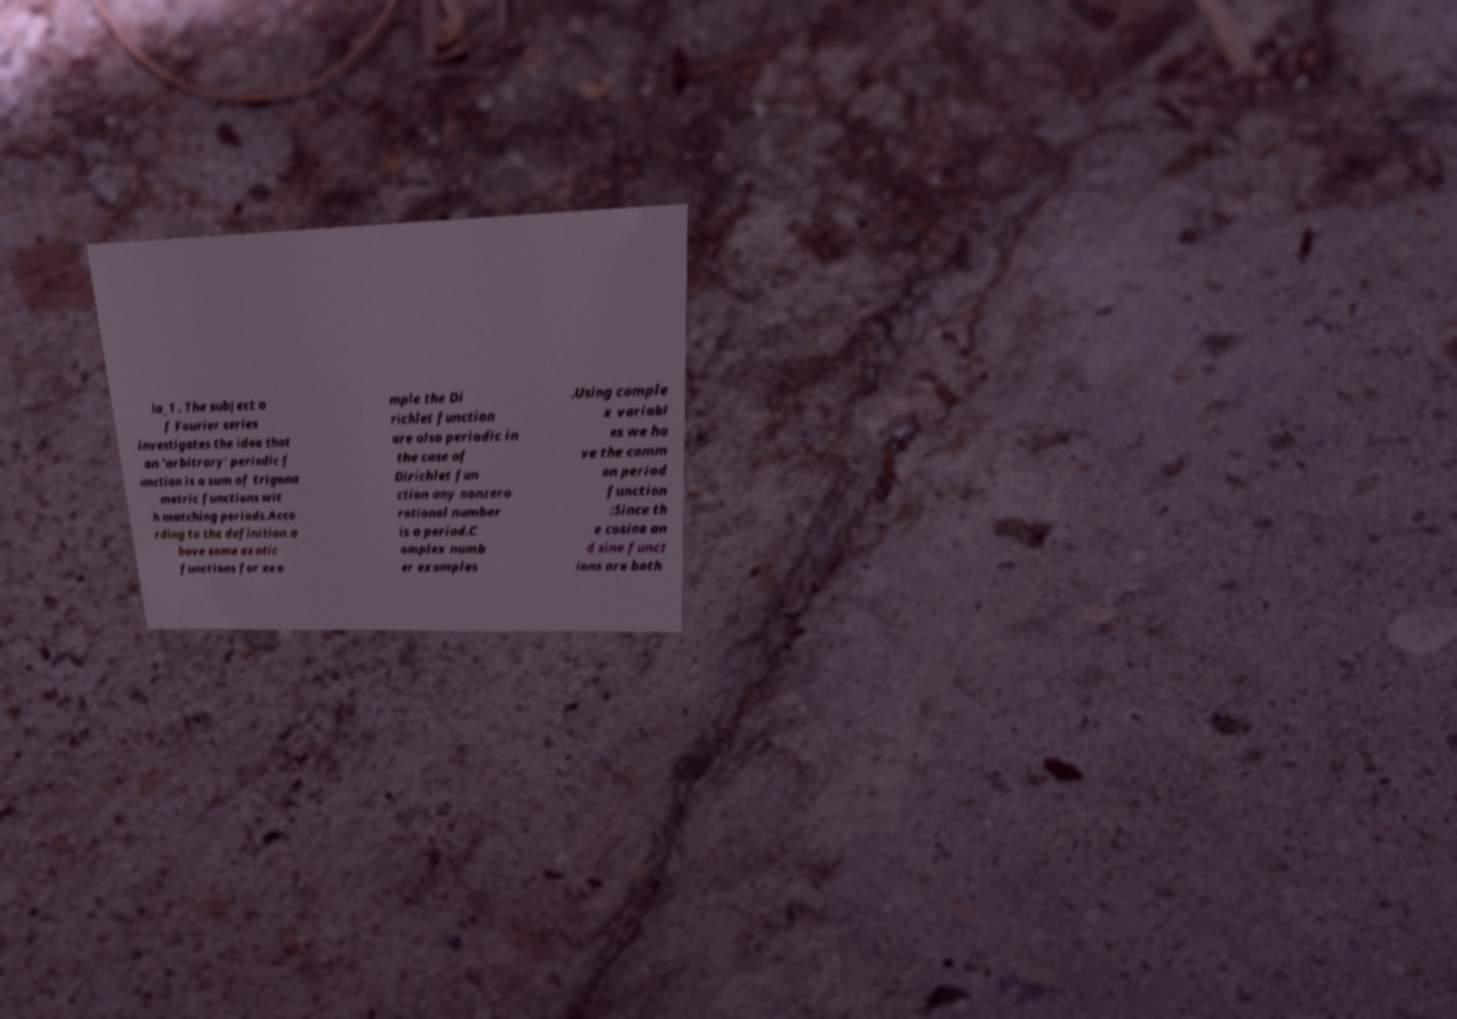Can you accurately transcribe the text from the provided image for me? la_1 . The subject o f Fourier series investigates the idea that an 'arbitrary' periodic f unction is a sum of trigono metric functions wit h matching periods.Acco rding to the definition a bove some exotic functions for exa mple the Di richlet function are also periodic in the case of Dirichlet fun ction any nonzero rational number is a period.C omplex numb er examples .Using comple x variabl es we ha ve the comm on period function :Since th e cosine an d sine funct ions are both 